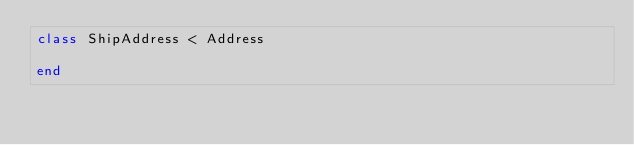<code> <loc_0><loc_0><loc_500><loc_500><_Ruby_>class ShipAddress < Address

end
</code> 